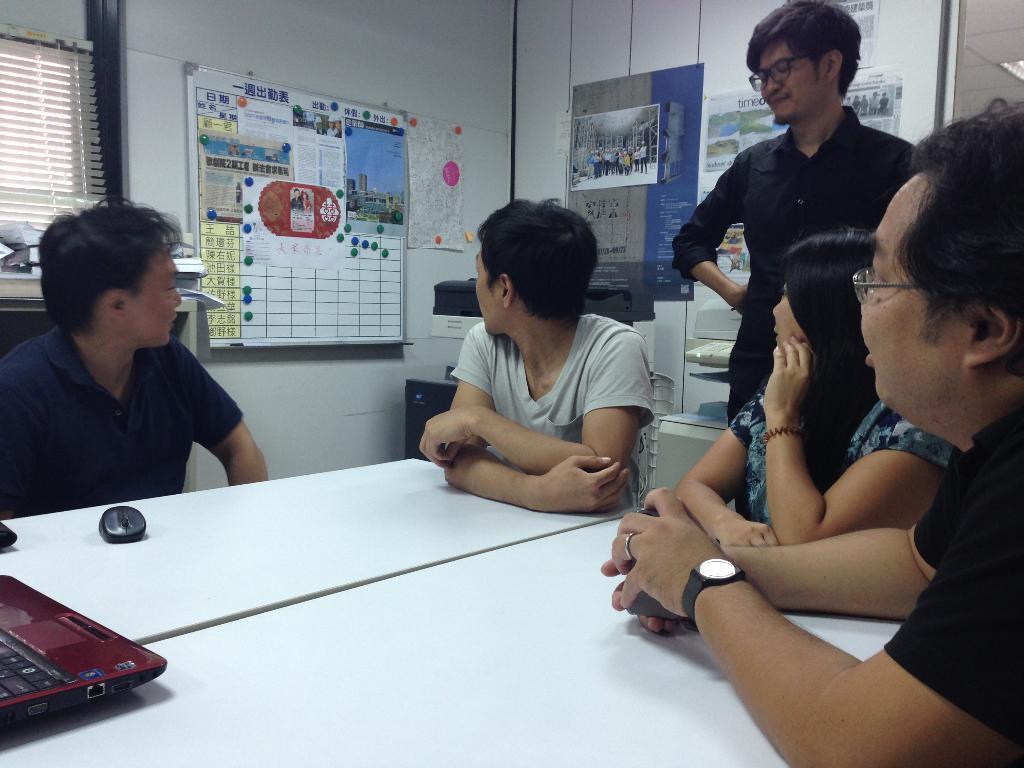How would you summarize this image in a sentence or two? This picture is clicked inside the room. Here, we see four people sitting on the chairs. Behind them, the man in the black shirt who is wearing spectacles is standing. In front of them, we see a white table on which laptop and mouse are placed. Behind them, we see a wall on which many posters are pasted. On the left side, we see a window blind. 